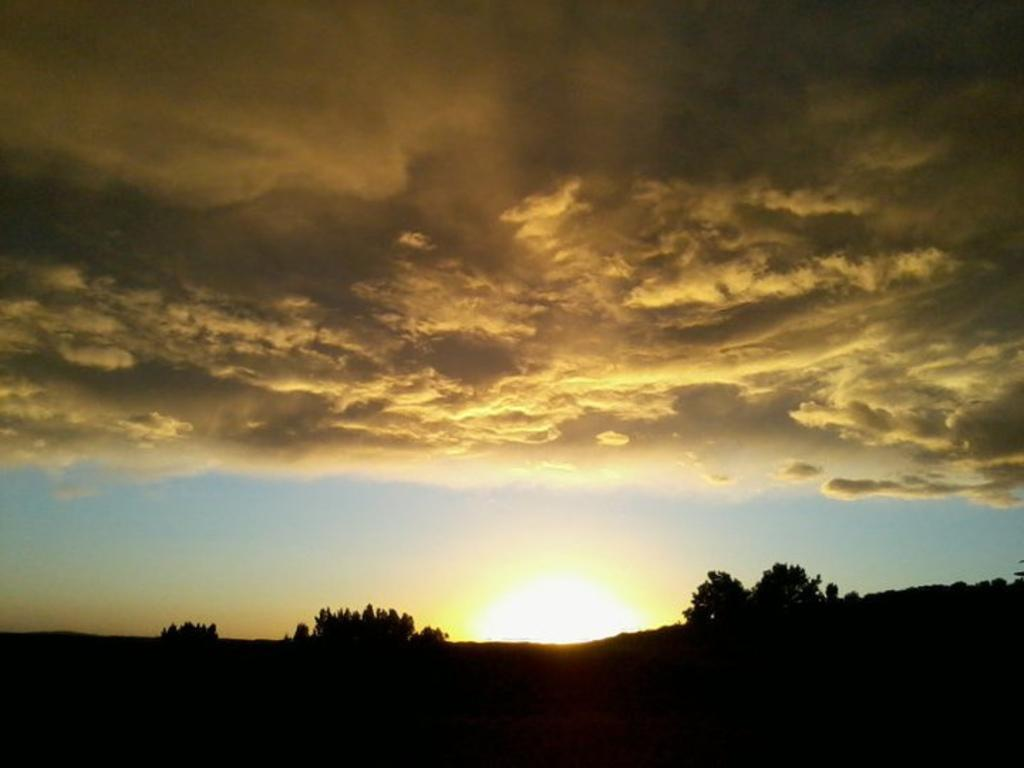What is located at the foreground of the image? There are trees at the foreground of the image. What is happening with the sun in the image? The sun is rising in the image. What is visible in the sky in the image? The sky is filled with clouds in the image. Can you see a woman painting a canvas in the image? There is no woman or canvas present in the image. What type of shell is visible in the image? There is no shell, such as a clam, present in the image. 